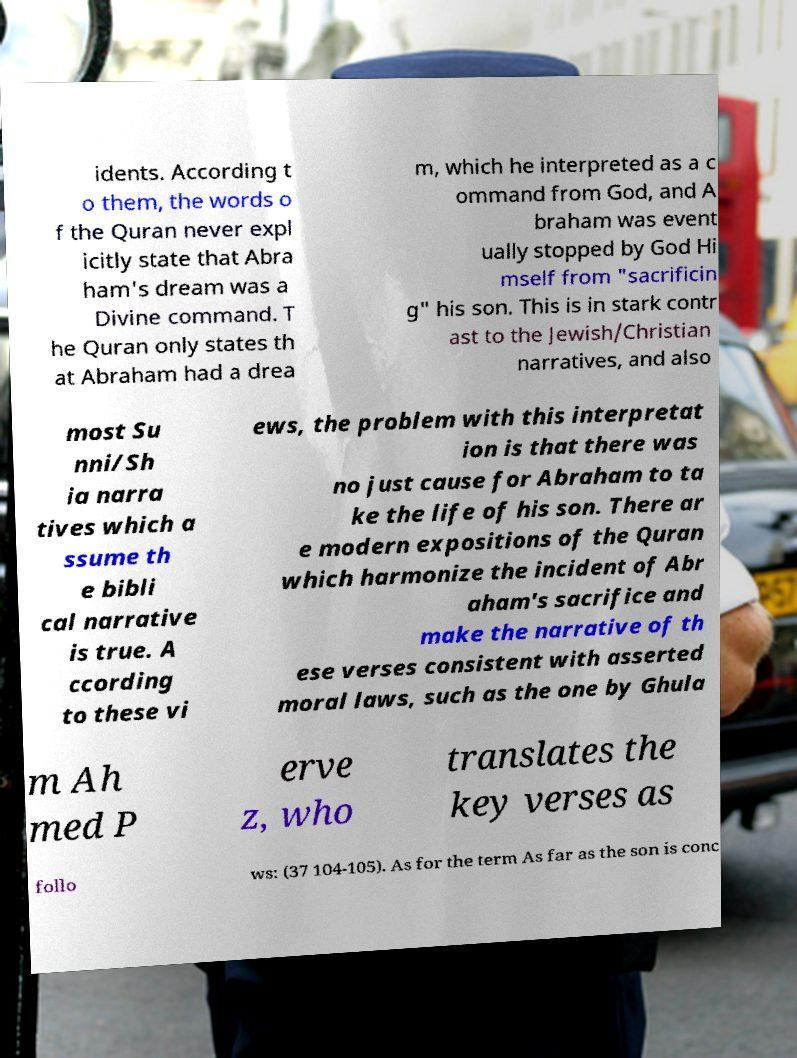Please identify and transcribe the text found in this image. idents. According t o them, the words o f the Quran never expl icitly state that Abra ham's dream was a Divine command. T he Quran only states th at Abraham had a drea m, which he interpreted as a c ommand from God, and A braham was event ually stopped by God Hi mself from "sacrificin g" his son. This is in stark contr ast to the Jewish/Christian narratives, and also most Su nni/Sh ia narra tives which a ssume th e bibli cal narrative is true. A ccording to these vi ews, the problem with this interpretat ion is that there was no just cause for Abraham to ta ke the life of his son. There ar e modern expositions of the Quran which harmonize the incident of Abr aham's sacrifice and make the narrative of th ese verses consistent with asserted moral laws, such as the one by Ghula m Ah med P erve z, who translates the key verses as follo ws: (37 104-105). As for the term As far as the son is conc 